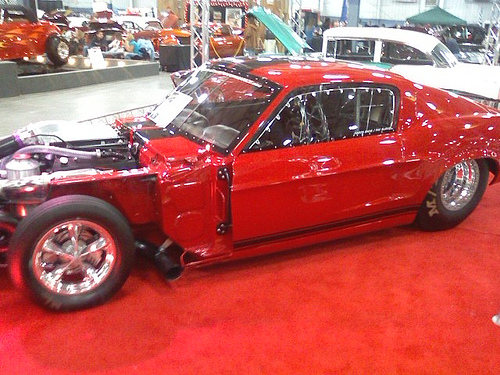<image>
Can you confirm if the hood is on the car? Yes. Looking at the image, I can see the hood is positioned on top of the car, with the car providing support. Is there a car on the floor? Yes. Looking at the image, I can see the car is positioned on top of the floor, with the floor providing support. 